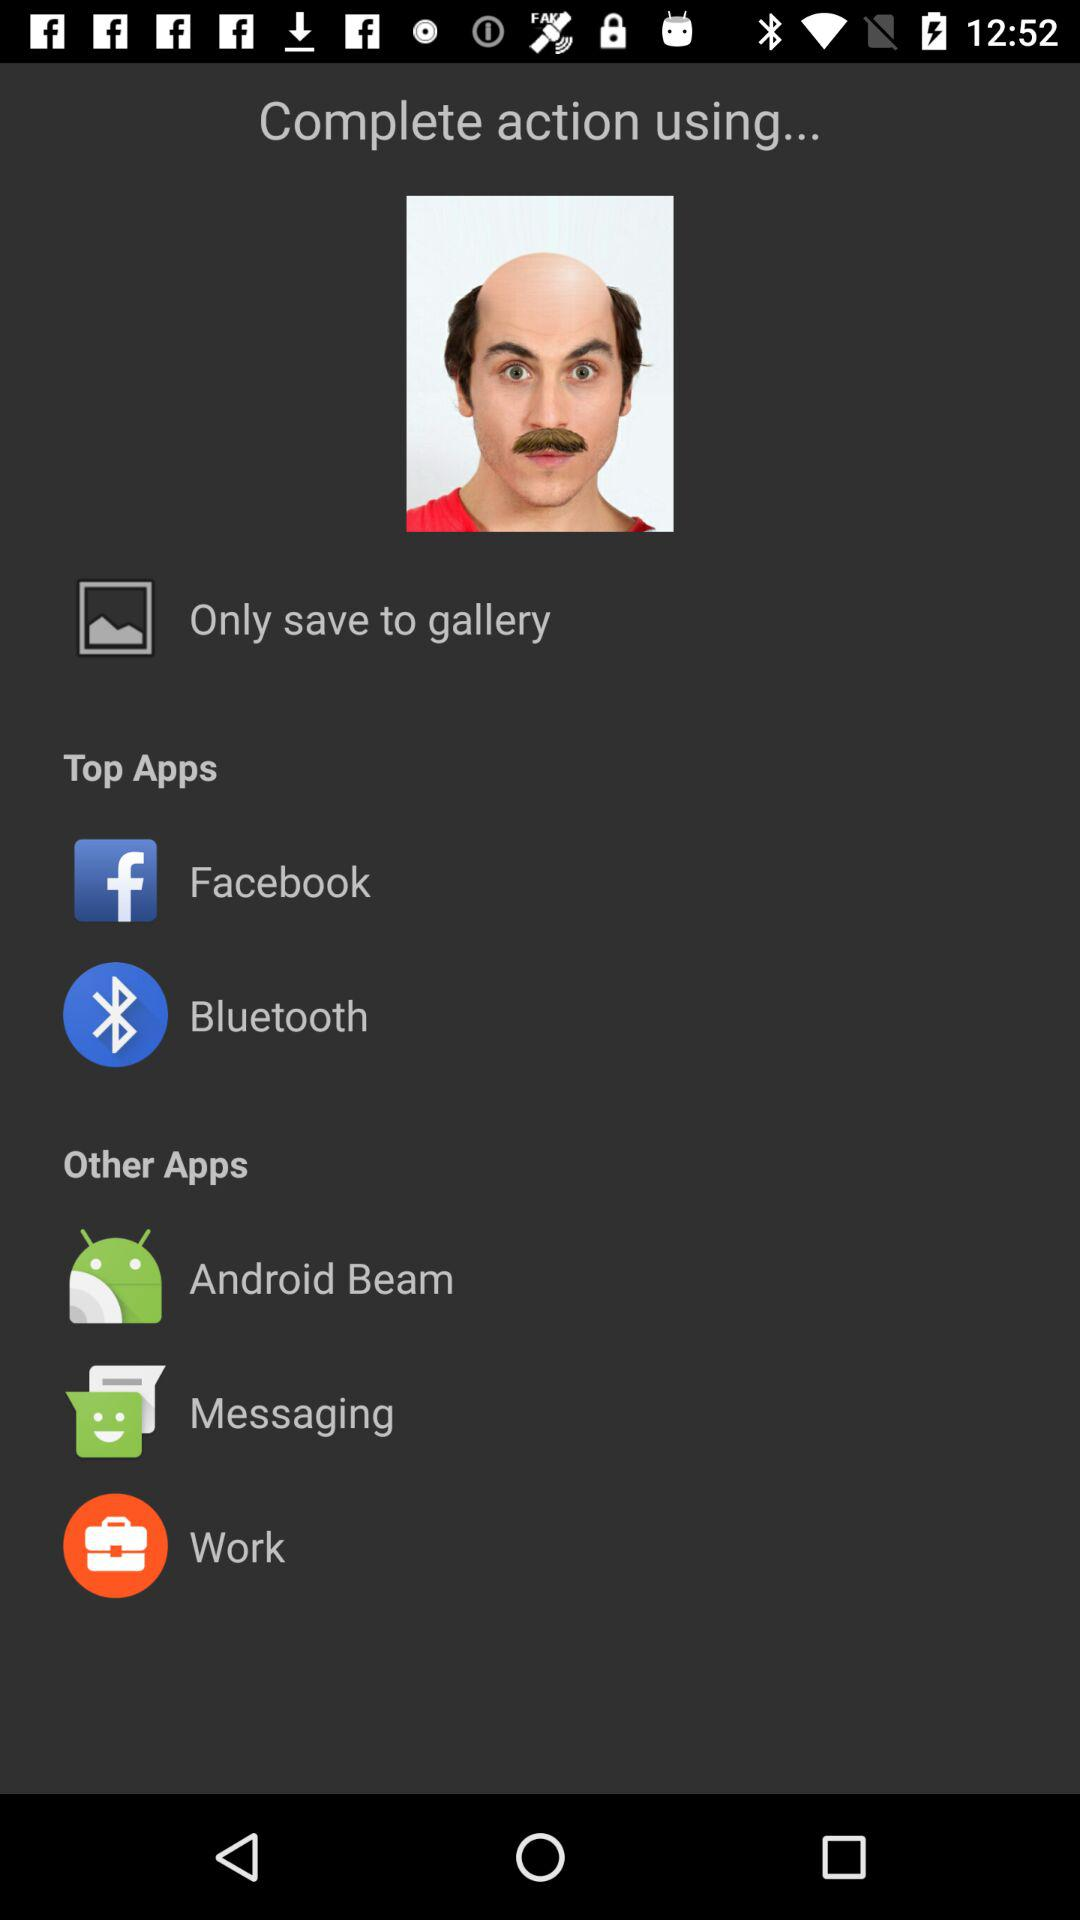What are the top applications? The top applications are "Facebook" and "Bluetooth". 